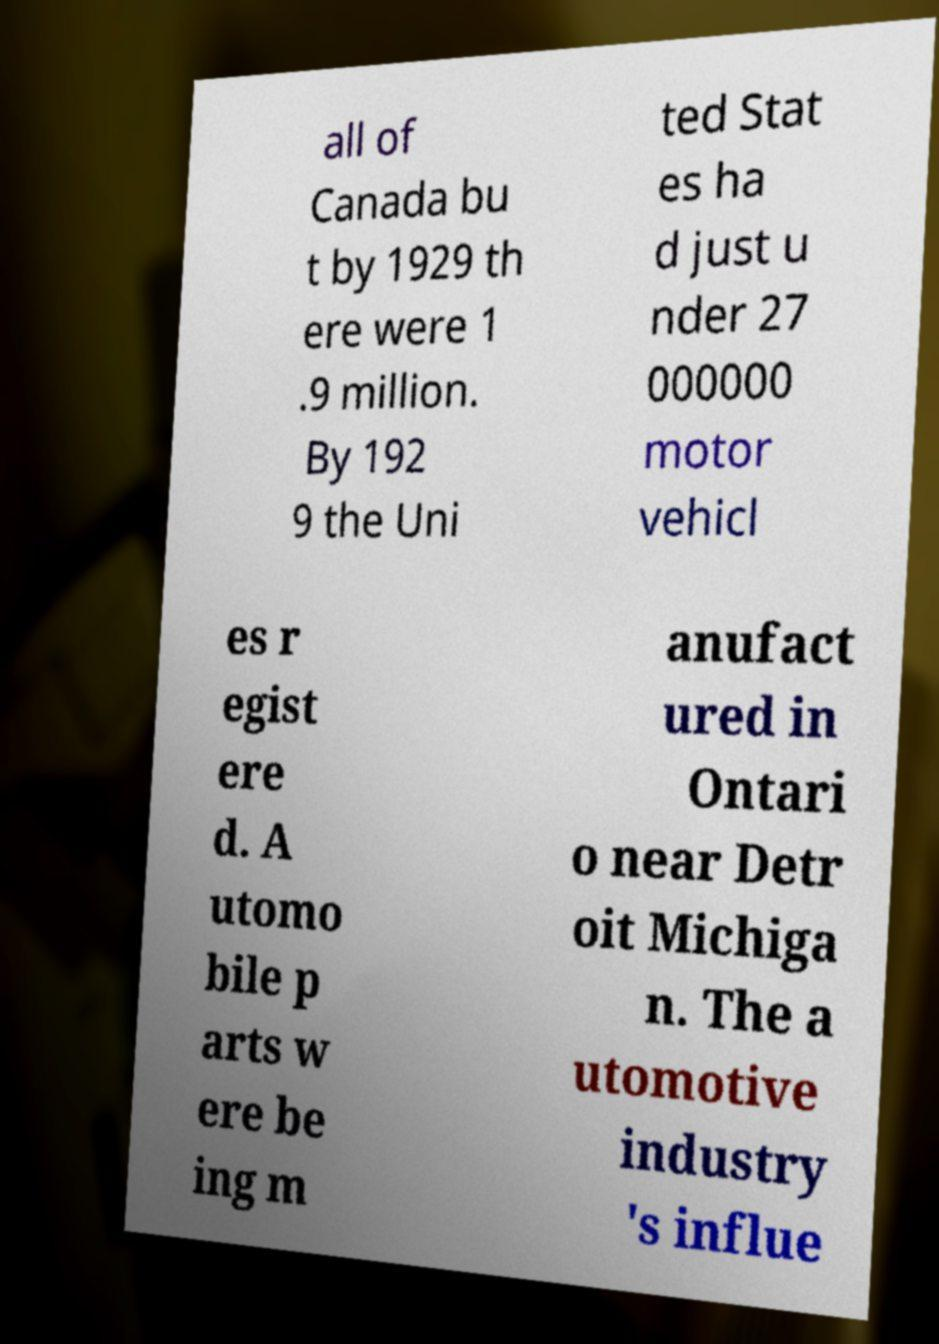For documentation purposes, I need the text within this image transcribed. Could you provide that? all of Canada bu t by 1929 th ere were 1 .9 million. By 192 9 the Uni ted Stat es ha d just u nder 27 000000 motor vehicl es r egist ere d. A utomo bile p arts w ere be ing m anufact ured in Ontari o near Detr oit Michiga n. The a utomotive industry 's influe 